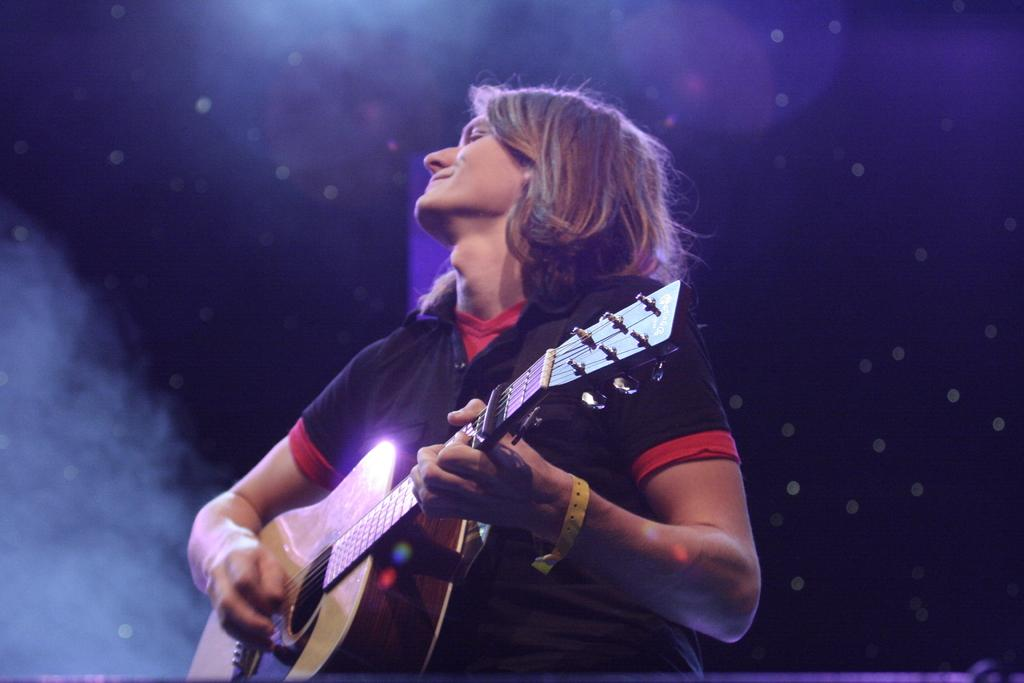What is the main subject of the image? There is a person in the image. What is the person doing in the image? The person is playing a guitar. What type of comfort can be seen in the image? There is no specific comfort depicted in the image; it features a person playing a guitar. How many feet are visible in the image? The number of feet visible in the image cannot be determined from the provided facts, as the image only shows a person playing a guitar. 